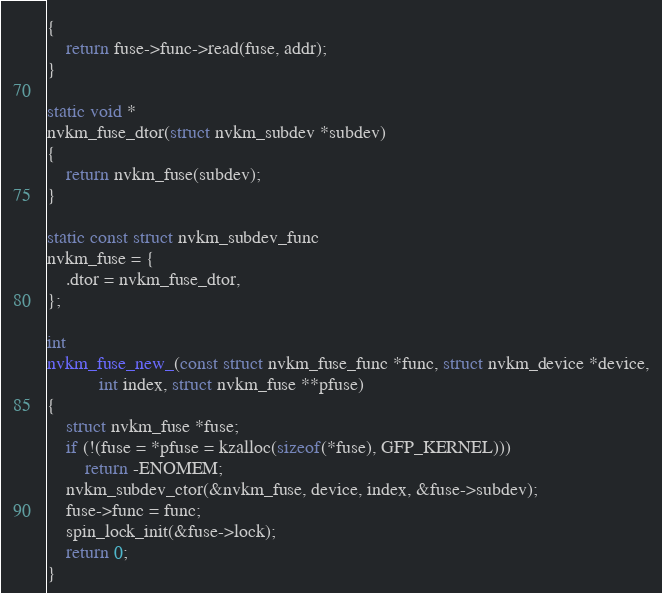Convert code to text. <code><loc_0><loc_0><loc_500><loc_500><_C_>{
	return fuse->func->read(fuse, addr);
}

static void *
nvkm_fuse_dtor(struct nvkm_subdev *subdev)
{
	return nvkm_fuse(subdev);
}

static const struct nvkm_subdev_func
nvkm_fuse = {
	.dtor = nvkm_fuse_dtor,
};

int
nvkm_fuse_new_(const struct nvkm_fuse_func *func, struct nvkm_device *device,
	       int index, struct nvkm_fuse **pfuse)
{
	struct nvkm_fuse *fuse;
	if (!(fuse = *pfuse = kzalloc(sizeof(*fuse), GFP_KERNEL)))
		return -ENOMEM;
	nvkm_subdev_ctor(&nvkm_fuse, device, index, &fuse->subdev);
	fuse->func = func;
	spin_lock_init(&fuse->lock);
	return 0;
}
</code> 